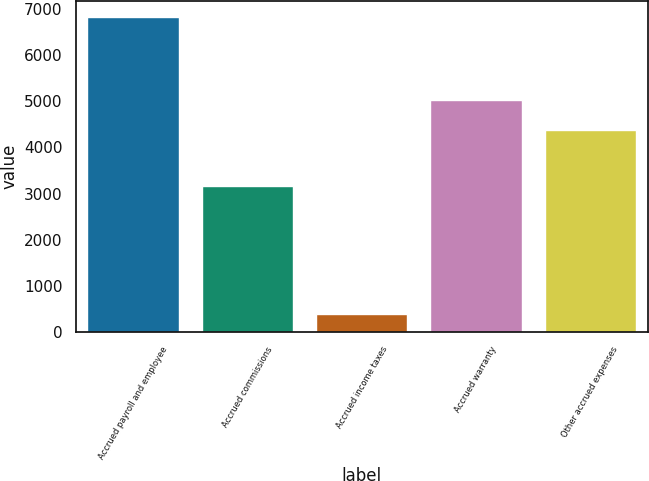Convert chart to OTSL. <chart><loc_0><loc_0><loc_500><loc_500><bar_chart><fcel>Accrued payroll and employee<fcel>Accrued commissions<fcel>Accrued income taxes<fcel>Accrued warranty<fcel>Other accrued expenses<nl><fcel>6828<fcel>3169<fcel>386<fcel>5026.2<fcel>4382<nl></chart> 